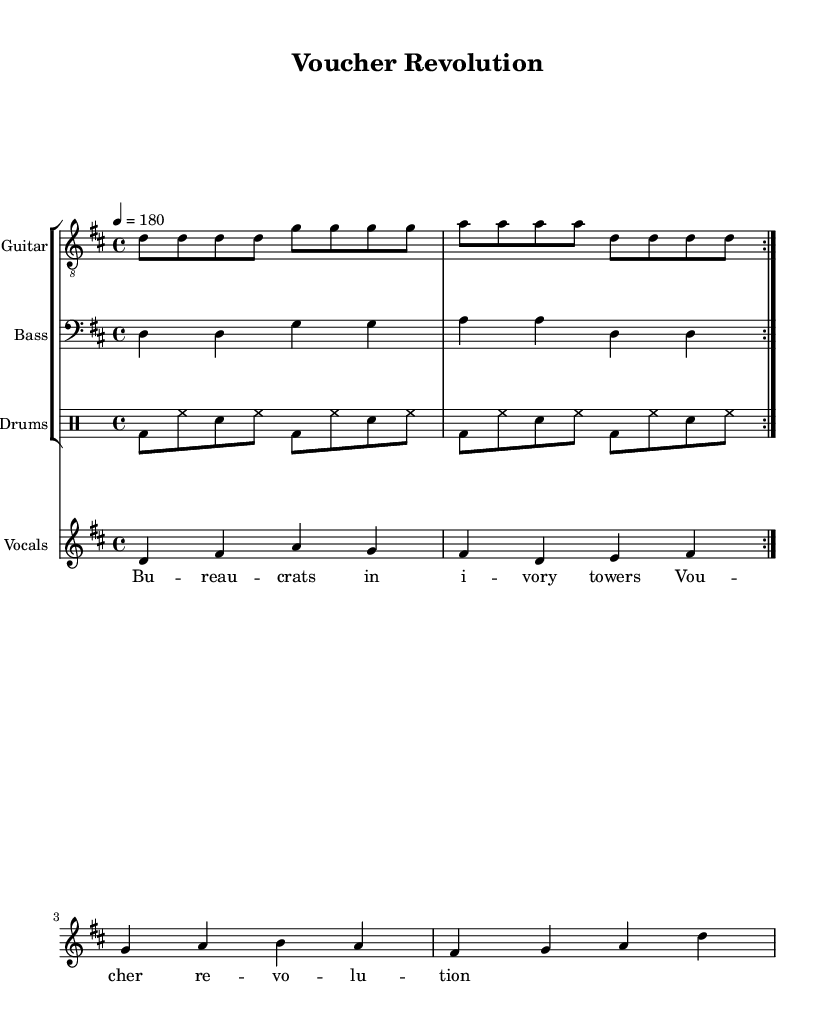What is the key signature of this music? The key signature appears at the beginning of the piece, indicating D major, which has two sharps (F# and C#).
Answer: D major What is the time signature of this music? The time signature is located at the start of the music sheet, shown as 4/4, which means there are four beats in a measure and the quarter note gets one beat.
Answer: 4/4 What is the tempo marking of this piece? The tempo marking is specified at the beginning, showing that the piece should be played at 180 beats per minute.
Answer: 180 How many times do the guitar and bass parts repeat? The repeat markings are indicated in the music where it states "volta 2," showing that both guitar and bass parts repeat two times.
Answer: 2 What mood or attitude does the lyrics convey? The lyrics critique government bureaucracy and suggest a revolution through vouchers, which reflects a rebellious and challenging attitude typical of punk rock.
Answer: Rebellious What voice type is used for the vocals? The music notation specifies the use of a treble clef for the vocals, indicating they should be sung by a higher vocal range, typically lead vocals in punk rock.
Answer: Treble How do the drum rhythms contribute to the punk style? The drumming features a steady fast-paced rhythm with bass and snare hits, contributing to the energetic and driving beat characteristic of punk music.
Answer: Driving energy 